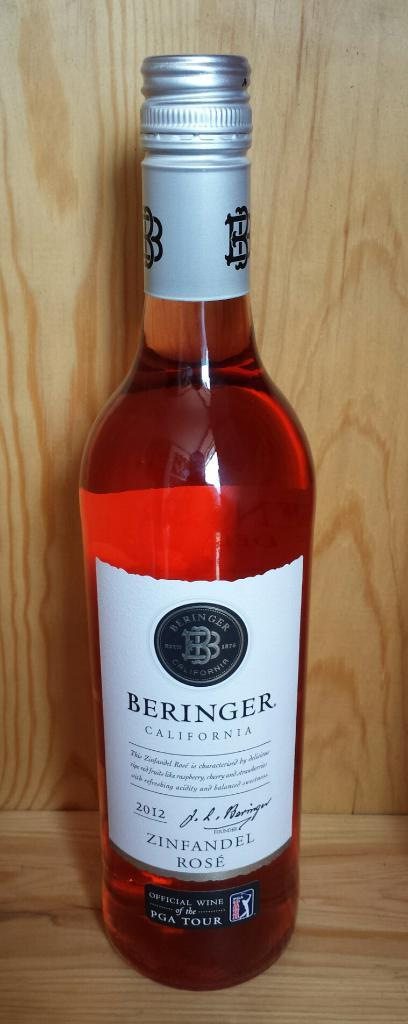What object is featured in the image? There is a bottle in the image. How is the bottle emphasized in the image? The bottle is highlighted in the image. Is there any additional information about the bottle? Yes, the bottle has a sticker. What type of wire is used to hold the frame of the bottle in the image? There is no wire or frame present in the image; it only features a bottle with a sticker. 